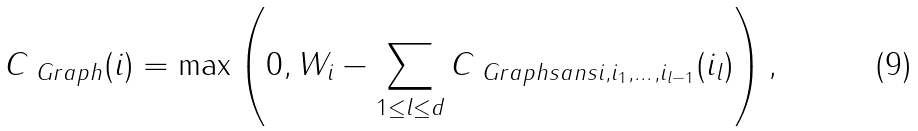Convert formula to latex. <formula><loc_0><loc_0><loc_500><loc_500>C _ { \ G r a p h } ( i ) = \max \left ( 0 , W _ { i } - \sum _ { 1 \leq l \leq d } C _ { \ G r a p h s a n s { i , i _ { 1 } , \dots , i _ { l - 1 } } } ( i _ { l } ) \right ) ,</formula> 